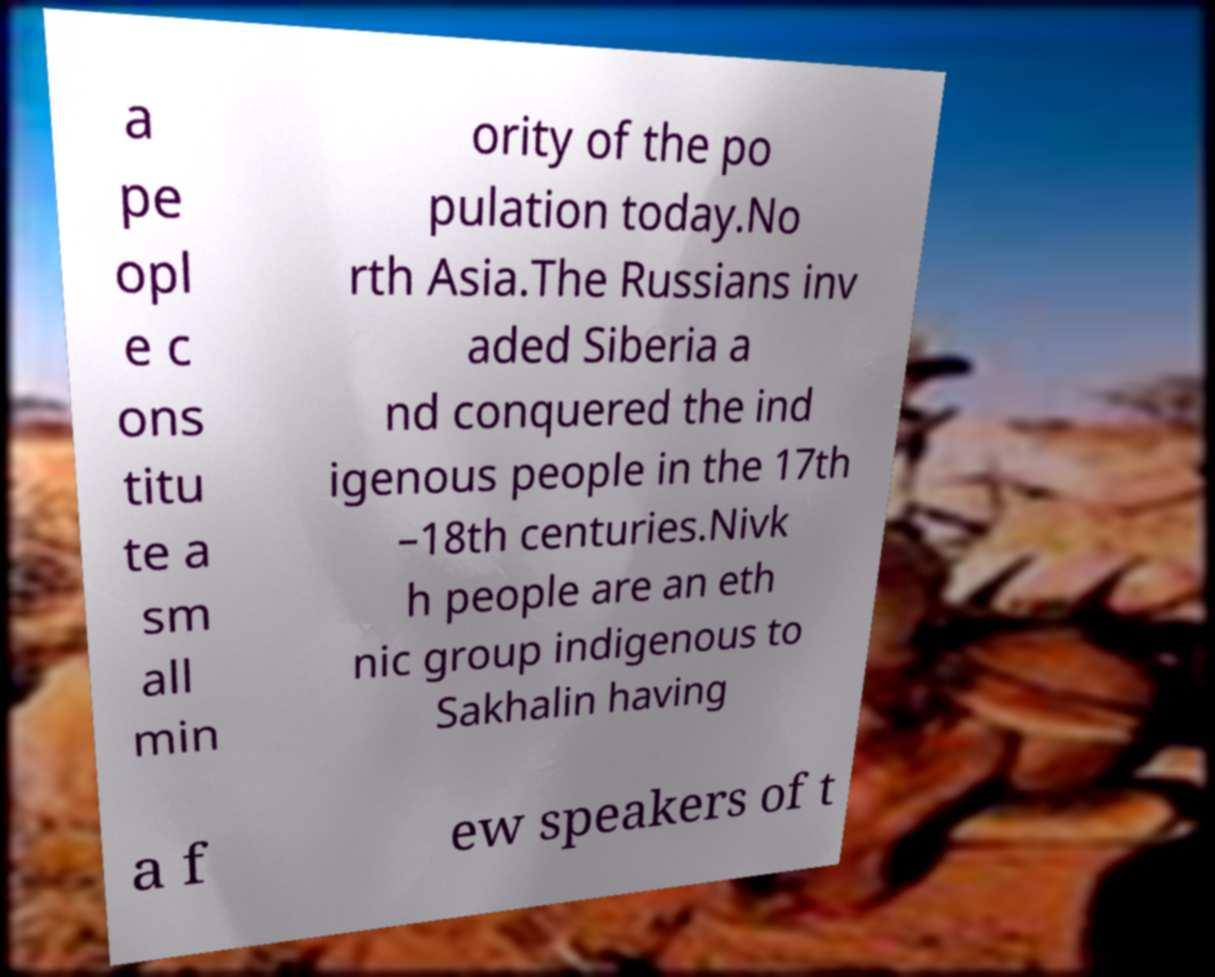Please identify and transcribe the text found in this image. a pe opl e c ons titu te a sm all min ority of the po pulation today.No rth Asia.The Russians inv aded Siberia a nd conquered the ind igenous people in the 17th –18th centuries.Nivk h people are an eth nic group indigenous to Sakhalin having a f ew speakers of t 